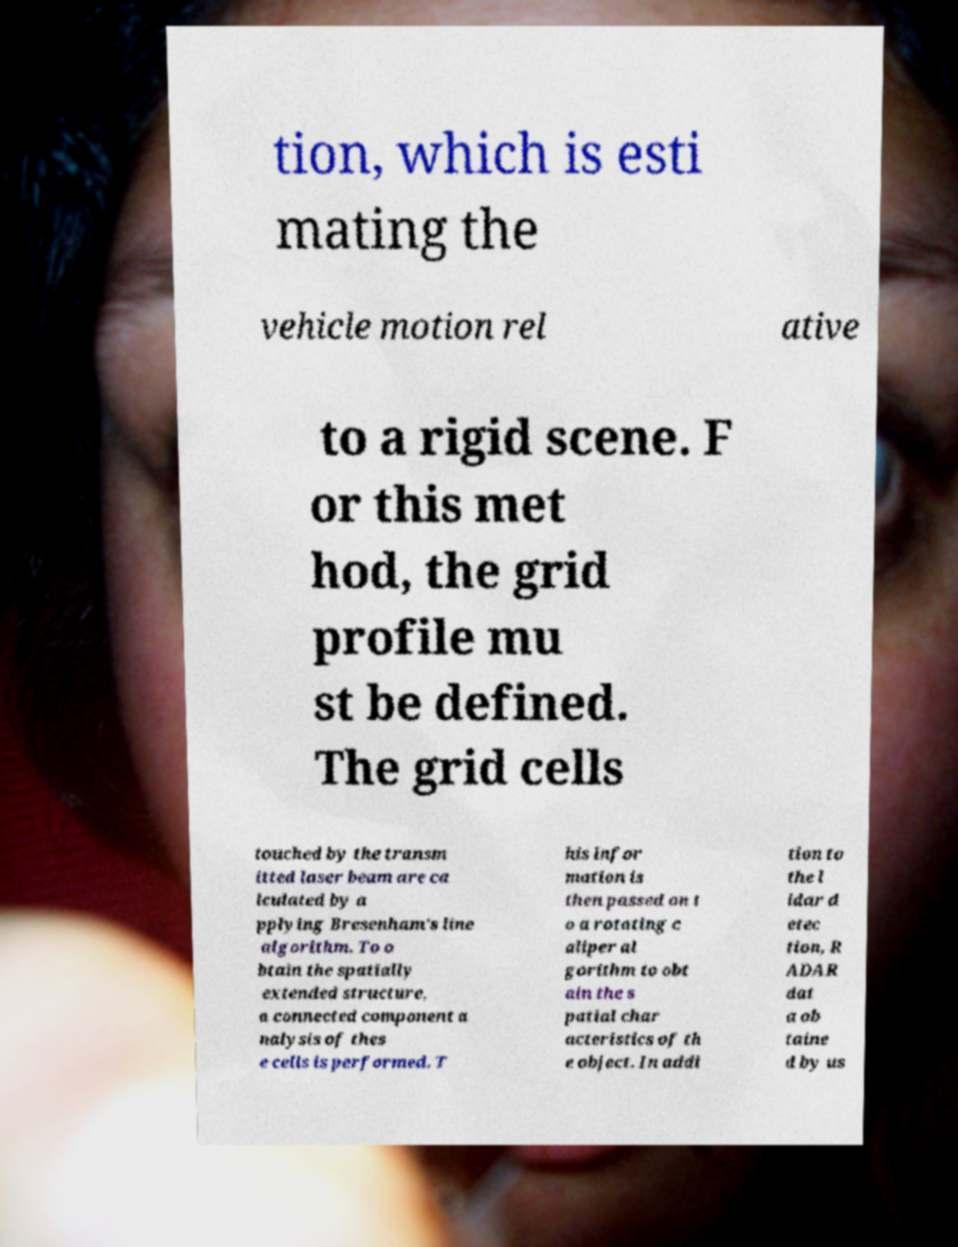Could you extract and type out the text from this image? tion, which is esti mating the vehicle motion rel ative to a rigid scene. F or this met hod, the grid profile mu st be defined. The grid cells touched by the transm itted laser beam are ca lculated by a pplying Bresenham's line algorithm. To o btain the spatially extended structure, a connected component a nalysis of thes e cells is performed. T his infor mation is then passed on t o a rotating c aliper al gorithm to obt ain the s patial char acteristics of th e object. In addi tion to the l idar d etec tion, R ADAR dat a ob taine d by us 